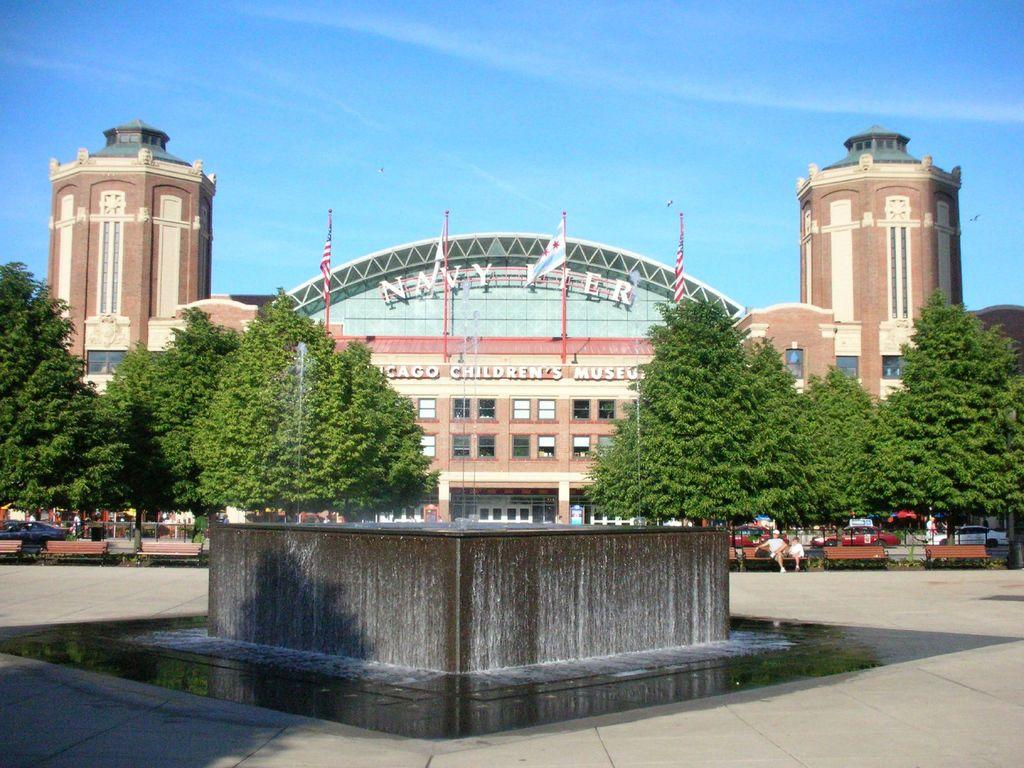What is located at the bottom of the image? There is a fountain at the bottom of the image. What type of vehicle can be seen in the image? There is a car in the image. Who or what is present in the image besides the fountain and car? There are people and trees in the image. What type of structure is visible in the image? There is a building in the image. What can be seen in the background of the image? The sky is visible in the background of the image. What type of committee is meeting in the image? There is no committee present in the image; it features a fountain, a car, people, trees, a building, and the sky. What color are the shoes worn by the people in the image? There is no information about shoes worn by the people in the image. 